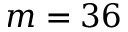Convert formula to latex. <formula><loc_0><loc_0><loc_500><loc_500>m = 3 6</formula> 